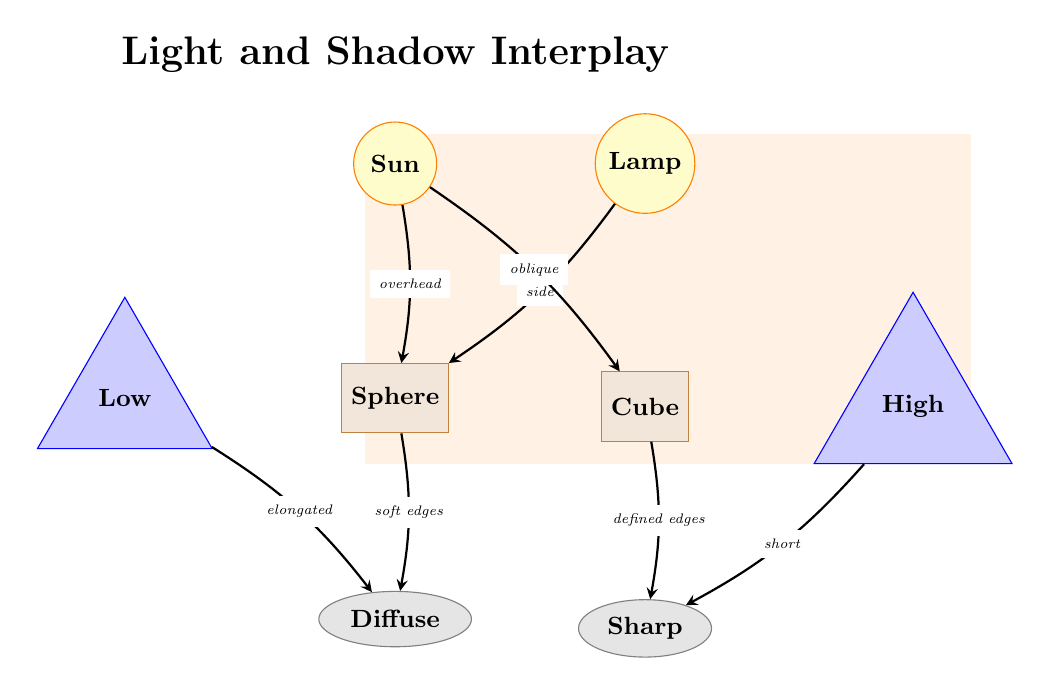What are the two light sources shown in the diagram? The diagram clearly labels two distinct light sources: the "Sun" and the "Lamp". Both are represented with circular nodes at the top of the diagram.
Answer: Sun, Lamp What type of shadow results from the sphere? The diagram indicates that the shadow resulting from the sphere is labeled as "Diffuse", which is shown below the sphere node.
Answer: Diffuse What is the relationship between the angle labeled "Low" and the shadow? The "Low" angle is connected to the "Diffuse" shadow node, indicating that it produces an elongated shadow as described by the label on the edge connecting them.
Answer: Elongated How many objects are depicted in this diagram? Upon reviewing the diagram, there are two objects shown: the "Sphere" and the "Cube". Each is labeled clearly within their respective rectangular nodes.
Answer: 2 What kind of edges does the shadow from the cube have? The diagram specifies that the shadow from the cube has "defined edges", as indicated by the label pointing from the cube node to the shadow node.
Answer: Defined edges What is the angle for the light source from the lamp? The angle when light comes from the lamp is indicated as "Side", as shown in the labeling pointing from the lamp to the sphere.
Answer: Side Which shadow is produced by the cube? The shadow produced by the cube is labeled in the diagram as "Sharp", depicted below the cube node.
Answer: Sharp Which light source produces a shadow with soft edges? According to the diagram, the "Sun" is the light source that creates a shadow with soft edges, leading to the "Diffuse" shadow on the diagram.
Answer: Sun 